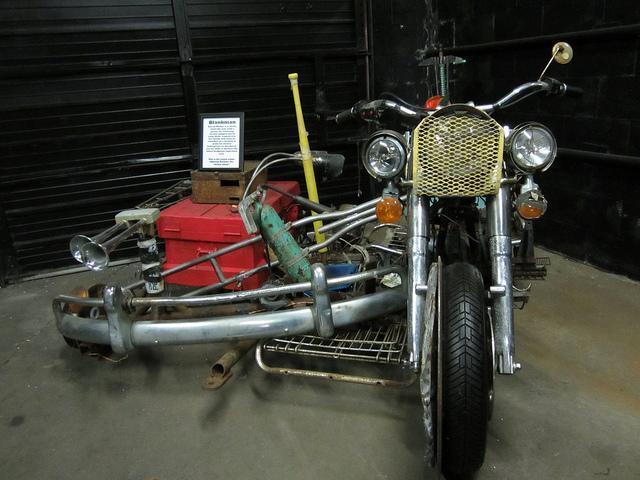How many bikes are in this area?
Give a very brief answer. 1. How many horses are there?
Give a very brief answer. 0. 